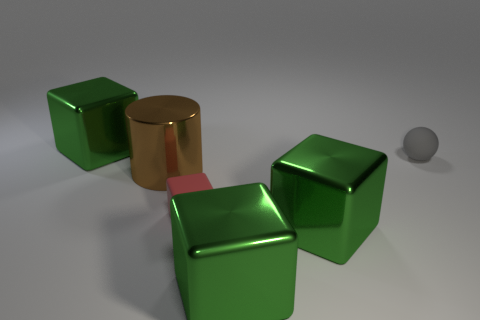Subtract all yellow blocks. Subtract all green cylinders. How many blocks are left? 4 Subtract all yellow spheres. How many blue cubes are left? 0 Add 3 small blues. How many small grays exist? 0 Subtract all small cyan cubes. Subtract all brown things. How many objects are left? 5 Add 3 large brown objects. How many large brown objects are left? 4 Add 5 matte objects. How many matte objects exist? 7 Add 3 big gray blocks. How many objects exist? 9 Subtract all green blocks. How many blocks are left? 1 Subtract all big green cubes. How many cubes are left? 1 Subtract 0 brown blocks. How many objects are left? 6 